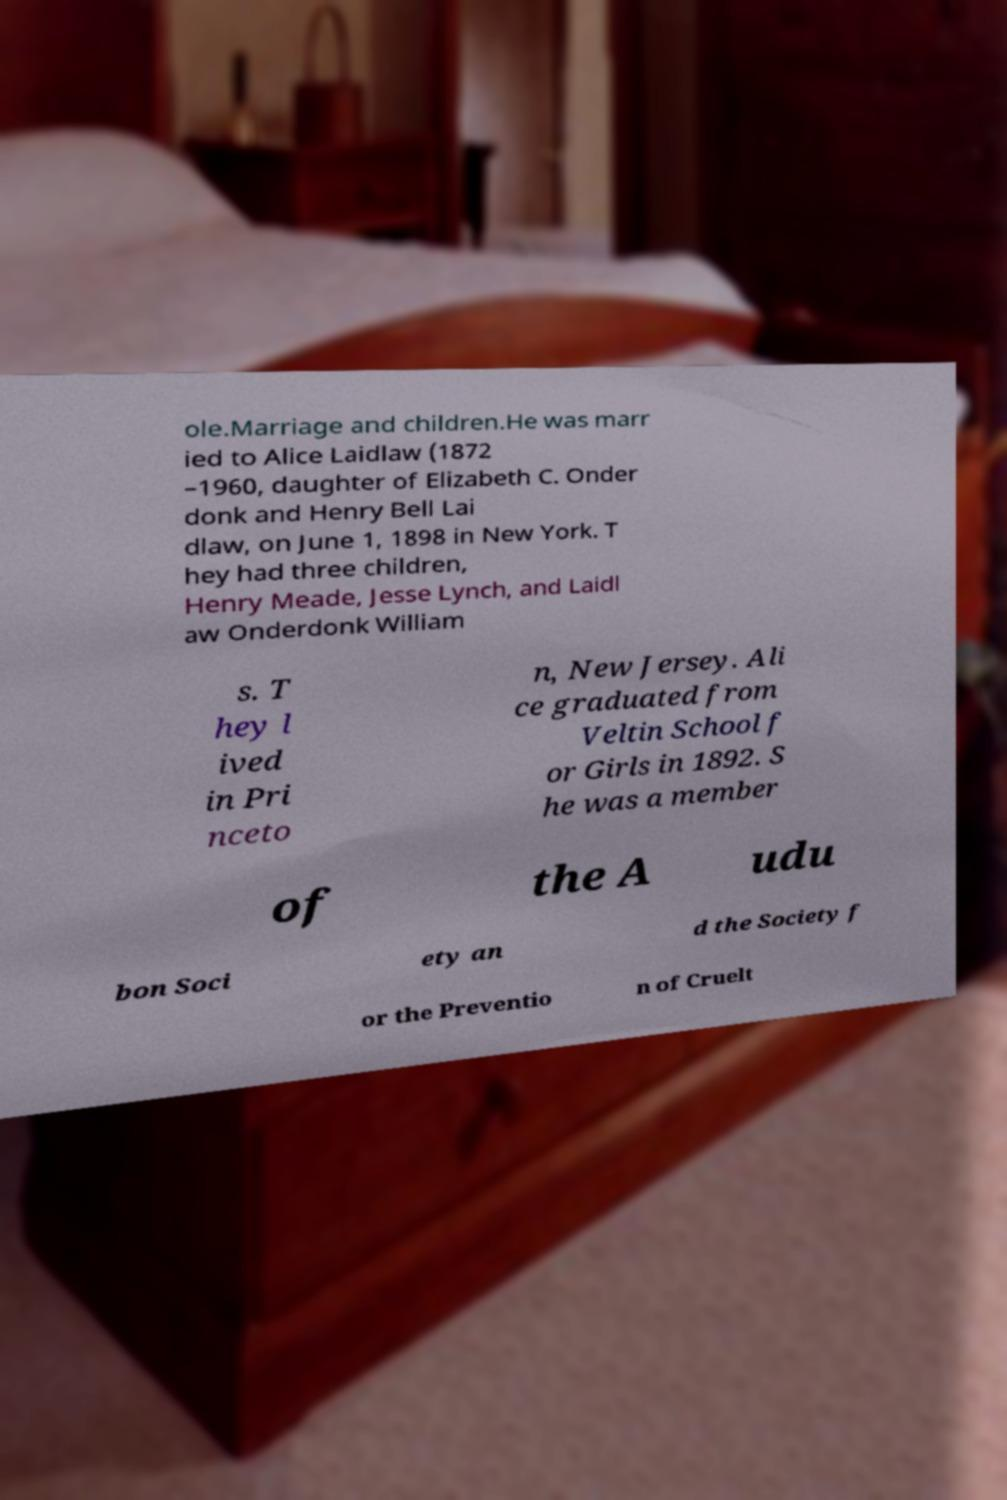Could you extract and type out the text from this image? ole.Marriage and children.He was marr ied to Alice Laidlaw (1872 –1960, daughter of Elizabeth C. Onder donk and Henry Bell Lai dlaw, on June 1, 1898 in New York. T hey had three children, Henry Meade, Jesse Lynch, and Laidl aw Onderdonk William s. T hey l ived in Pri nceto n, New Jersey. Ali ce graduated from Veltin School f or Girls in 1892. S he was a member of the A udu bon Soci ety an d the Society f or the Preventio n of Cruelt 